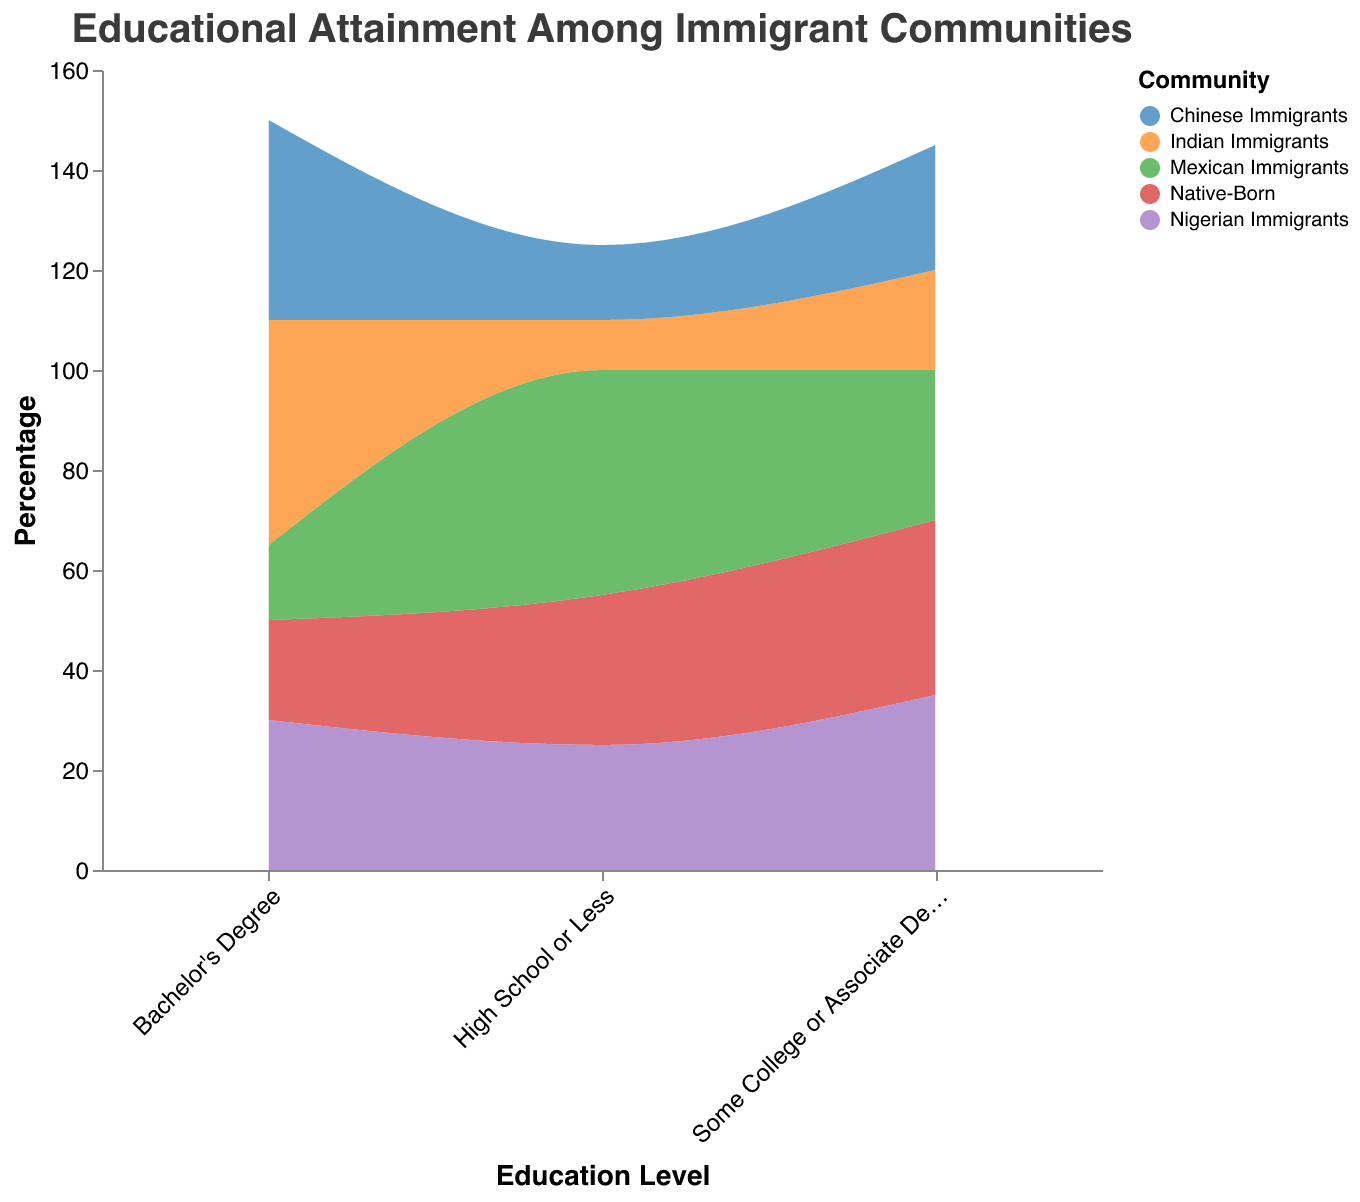What is the title of the plot? The title of the plot is displayed at the top of the figure and provides a summary of what the plot is about. In this case, it is "Educational Attainment Among Immigrant Communities".
Answer: Educational Attainment Among Immigrant Communities Which community has the highest percentage of individuals with a Bachelor’s Degree? To find this, look for the highest value in the Bachelor's Degree category across all communities. Indian immigrants have the highest percentage with 45%.
Answer: Indian Immigrants What is the percentage of Native-Born citizens who have completed high school or less? Locate the Native-Born community in the "High School or Less" category. The percentage listed is 30%.
Answer: 30% Which community has the lowest percentage of individuals with a Bachelor's Degree? Identify the community with the smallest percentage in the Bachelor's Degree category. Mexican immigrants have the lowest percentage, with 15%.
Answer: Mexican Immigrants How does the percentage of Nigerian Immigrants with some college or an associate degree compare to Native-Born citizens with the same educational level? Compare the values in the "Some College or Associate Degree" category for both groups. Both Nigerian Immigrants and Native-Born citizens have the same percentage, which is 35%.
Answer: They are equal What is the difference in the percentage of Mexican Immigrants and Indian Immigrants with a Bachelor's Degree? Identify the percentages of Mexican Immigrants (15%) and Indian Immigrants (45%) with a Bachelor's Degree, then calculate the difference: 45% - 15% = 30%.
Answer: 30% Which community has the highest percentage of individuals with high school or less education? Find the highest percentage in the "High School or Less" category across all communities. Mexican Immigrants have the highest percentage with 45%.
Answer: Mexican Immigrants What is the average percentage of individuals with a Bachelor's Degree across all communities? Add the percentages of each community within the Bachelor's Degree category (20 + 15 + 45 + 40 + 30) and divide by 5. The sum is 150, and the average is 150/5 = 30%.
Answer: 30% Is the percentage of Indian Immigrants with a high school or less education greater than or less than that of Nigerian Immigrants? Compare the percentages for Indian Immigrants (10%) and Nigerian Immigrants (25%) in the "High School or Less" category. Indian Immigrants have a lower percentage than Nigerian Immigrants.
Answer: Less than What is the total percentage for all education levels of the Native-Born community? Sum the percentages for all education levels of the Native-Born community (30 + 35 + 20). The total is 85%.
Answer: 85% 